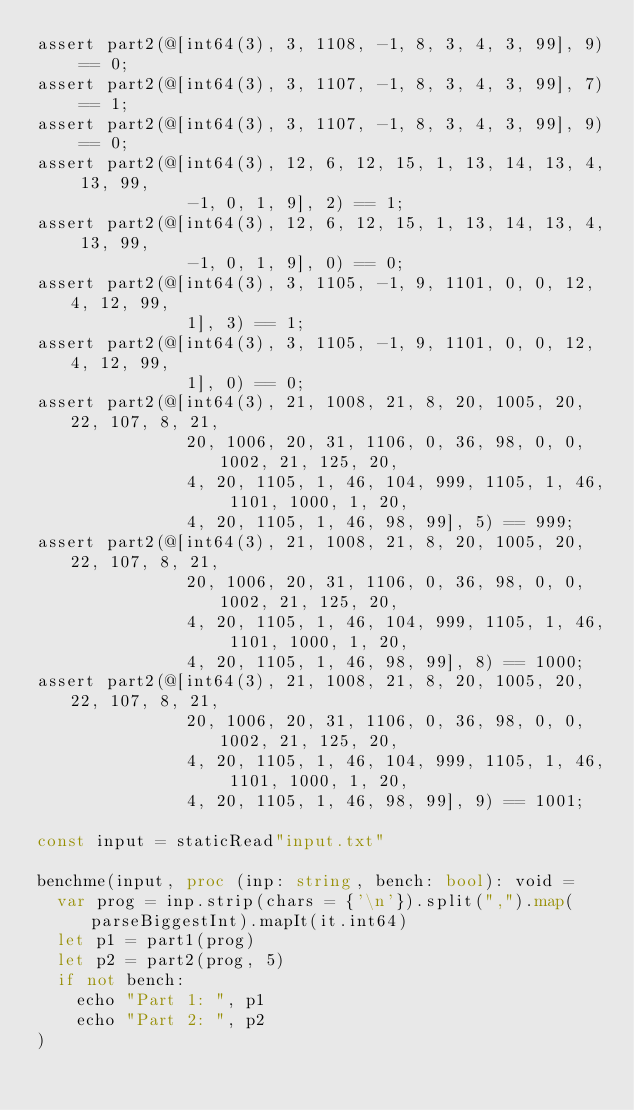Convert code to text. <code><loc_0><loc_0><loc_500><loc_500><_Nim_>assert part2(@[int64(3), 3, 1108, -1, 8, 3, 4, 3, 99], 9) == 0;
assert part2(@[int64(3), 3, 1107, -1, 8, 3, 4, 3, 99], 7) == 1;
assert part2(@[int64(3), 3, 1107, -1, 8, 3, 4, 3, 99], 9) == 0;
assert part2(@[int64(3), 12, 6, 12, 15, 1, 13, 14, 13, 4, 13, 99,
               -1, 0, 1, 9], 2) == 1;
assert part2(@[int64(3), 12, 6, 12, 15, 1, 13, 14, 13, 4, 13, 99,
               -1, 0, 1, 9], 0) == 0;
assert part2(@[int64(3), 3, 1105, -1, 9, 1101, 0, 0, 12, 4, 12, 99,
               1], 3) == 1;
assert part2(@[int64(3), 3, 1105, -1, 9, 1101, 0, 0, 12, 4, 12, 99,
               1], 0) == 0;
assert part2(@[int64(3), 21, 1008, 21, 8, 20, 1005, 20, 22, 107, 8, 21,
               20, 1006, 20, 31, 1106, 0, 36, 98, 0, 0, 1002, 21, 125, 20,
               4, 20, 1105, 1, 46, 104, 999, 1105, 1, 46, 1101, 1000, 1, 20,
               4, 20, 1105, 1, 46, 98, 99], 5) == 999;
assert part2(@[int64(3), 21, 1008, 21, 8, 20, 1005, 20, 22, 107, 8, 21,
               20, 1006, 20, 31, 1106, 0, 36, 98, 0, 0, 1002, 21, 125, 20,
               4, 20, 1105, 1, 46, 104, 999, 1105, 1, 46, 1101, 1000, 1, 20,
               4, 20, 1105, 1, 46, 98, 99], 8) == 1000;
assert part2(@[int64(3), 21, 1008, 21, 8, 20, 1005, 20, 22, 107, 8, 21,
               20, 1006, 20, 31, 1106, 0, 36, 98, 0, 0, 1002, 21, 125, 20,
               4, 20, 1105, 1, 46, 104, 999, 1105, 1, 46, 1101, 1000, 1, 20,
               4, 20, 1105, 1, 46, 98, 99], 9) == 1001;

const input = staticRead"input.txt"

benchme(input, proc (inp: string, bench: bool): void =
  var prog = inp.strip(chars = {'\n'}).split(",").map(parseBiggestInt).mapIt(it.int64)
  let p1 = part1(prog)
  let p2 = part2(prog, 5)
  if not bench:
    echo "Part 1: ", p1
    echo "Part 2: ", p2
)
</code> 